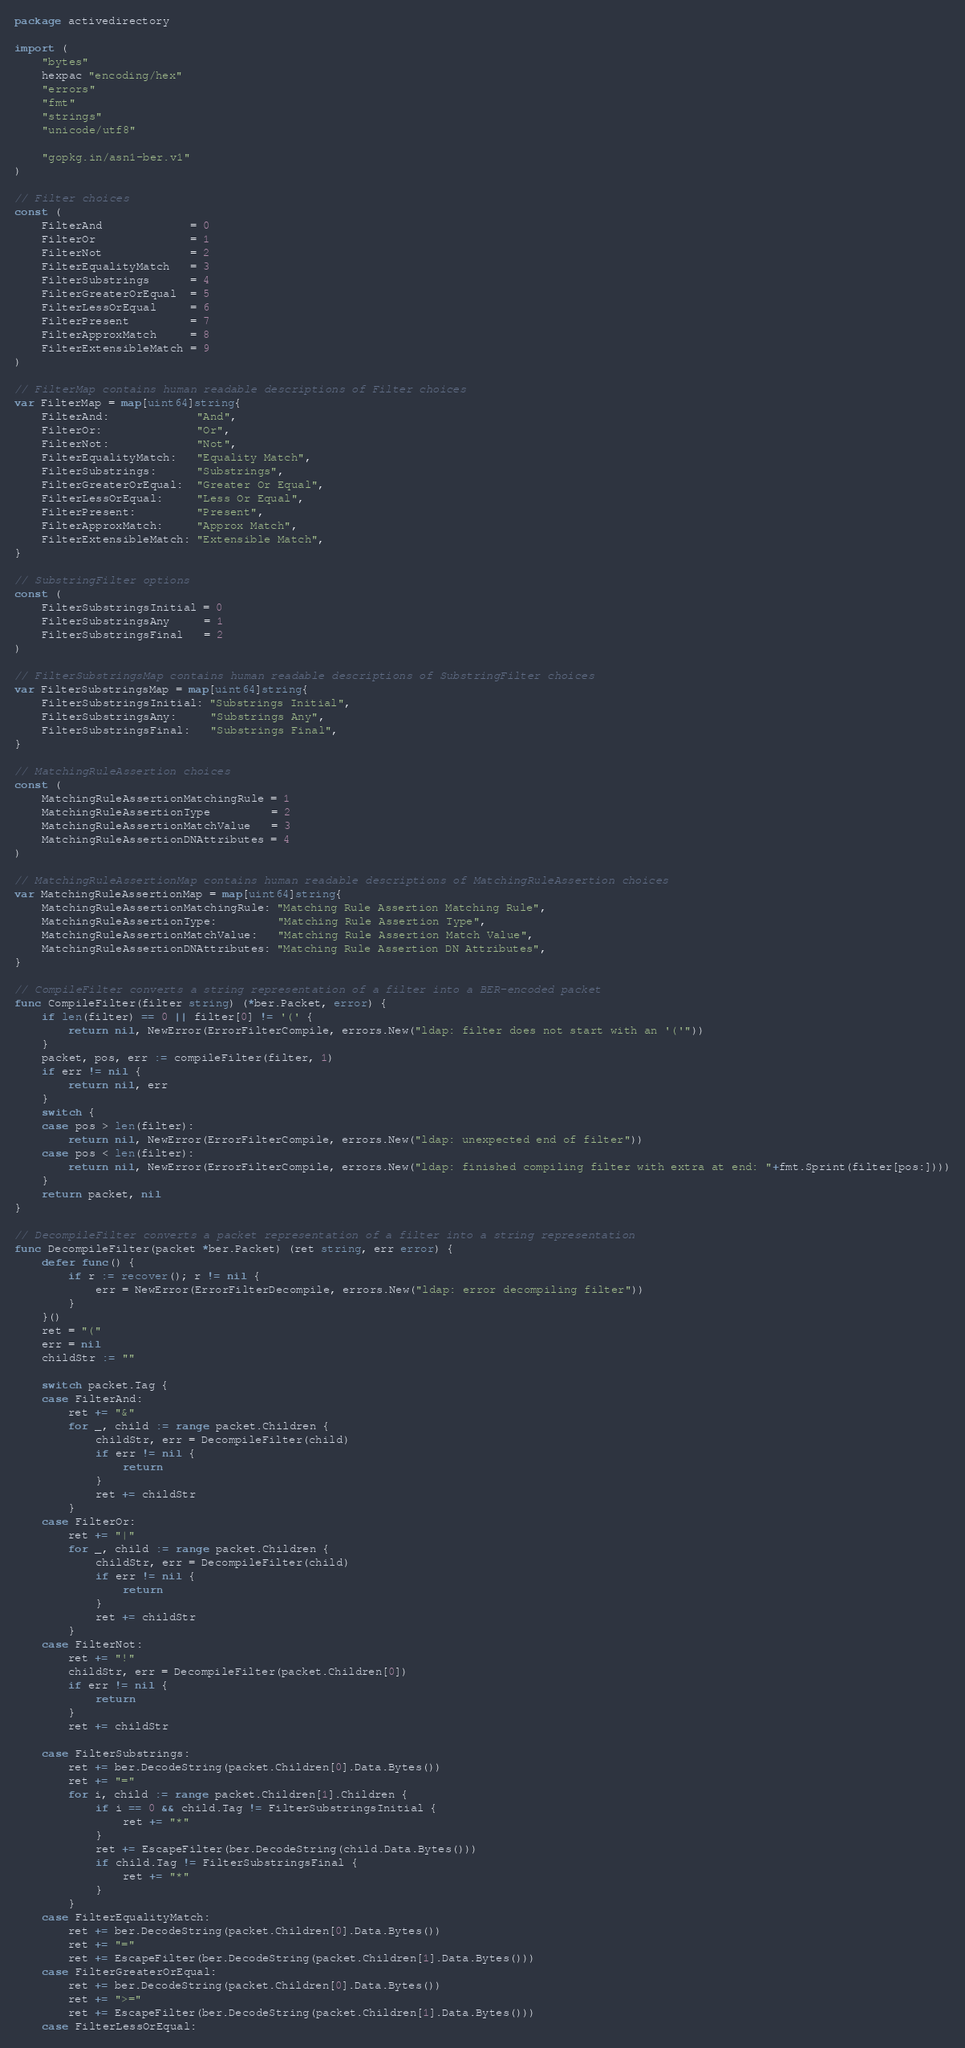Convert code to text. <code><loc_0><loc_0><loc_500><loc_500><_Go_>package activedirectory

import (
	"bytes"
	hexpac "encoding/hex"
	"errors"
	"fmt"
	"strings"
	"unicode/utf8"

	"gopkg.in/asn1-ber.v1"
)

// Filter choices
const (
	FilterAnd             = 0
	FilterOr              = 1
	FilterNot             = 2
	FilterEqualityMatch   = 3
	FilterSubstrings      = 4
	FilterGreaterOrEqual  = 5
	FilterLessOrEqual     = 6
	FilterPresent         = 7
	FilterApproxMatch     = 8
	FilterExtensibleMatch = 9
)

// FilterMap contains human readable descriptions of Filter choices
var FilterMap = map[uint64]string{
	FilterAnd:             "And",
	FilterOr:              "Or",
	FilterNot:             "Not",
	FilterEqualityMatch:   "Equality Match",
	FilterSubstrings:      "Substrings",
	FilterGreaterOrEqual:  "Greater Or Equal",
	FilterLessOrEqual:     "Less Or Equal",
	FilterPresent:         "Present",
	FilterApproxMatch:     "Approx Match",
	FilterExtensibleMatch: "Extensible Match",
}

// SubstringFilter options
const (
	FilterSubstringsInitial = 0
	FilterSubstringsAny     = 1
	FilterSubstringsFinal   = 2
)

// FilterSubstringsMap contains human readable descriptions of SubstringFilter choices
var FilterSubstringsMap = map[uint64]string{
	FilterSubstringsInitial: "Substrings Initial",
	FilterSubstringsAny:     "Substrings Any",
	FilterSubstringsFinal:   "Substrings Final",
}

// MatchingRuleAssertion choices
const (
	MatchingRuleAssertionMatchingRule = 1
	MatchingRuleAssertionType         = 2
	MatchingRuleAssertionMatchValue   = 3
	MatchingRuleAssertionDNAttributes = 4
)

// MatchingRuleAssertionMap contains human readable descriptions of MatchingRuleAssertion choices
var MatchingRuleAssertionMap = map[uint64]string{
	MatchingRuleAssertionMatchingRule: "Matching Rule Assertion Matching Rule",
	MatchingRuleAssertionType:         "Matching Rule Assertion Type",
	MatchingRuleAssertionMatchValue:   "Matching Rule Assertion Match Value",
	MatchingRuleAssertionDNAttributes: "Matching Rule Assertion DN Attributes",
}

// CompileFilter converts a string representation of a filter into a BER-encoded packet
func CompileFilter(filter string) (*ber.Packet, error) {
	if len(filter) == 0 || filter[0] != '(' {
		return nil, NewError(ErrorFilterCompile, errors.New("ldap: filter does not start with an '('"))
	}
	packet, pos, err := compileFilter(filter, 1)
	if err != nil {
		return nil, err
	}
	switch {
	case pos > len(filter):
		return nil, NewError(ErrorFilterCompile, errors.New("ldap: unexpected end of filter"))
	case pos < len(filter):
		return nil, NewError(ErrorFilterCompile, errors.New("ldap: finished compiling filter with extra at end: "+fmt.Sprint(filter[pos:])))
	}
	return packet, nil
}

// DecompileFilter converts a packet representation of a filter into a string representation
func DecompileFilter(packet *ber.Packet) (ret string, err error) {
	defer func() {
		if r := recover(); r != nil {
			err = NewError(ErrorFilterDecompile, errors.New("ldap: error decompiling filter"))
		}
	}()
	ret = "("
	err = nil
	childStr := ""

	switch packet.Tag {
	case FilterAnd:
		ret += "&"
		for _, child := range packet.Children {
			childStr, err = DecompileFilter(child)
			if err != nil {
				return
			}
			ret += childStr
		}
	case FilterOr:
		ret += "|"
		for _, child := range packet.Children {
			childStr, err = DecompileFilter(child)
			if err != nil {
				return
			}
			ret += childStr
		}
	case FilterNot:
		ret += "!"
		childStr, err = DecompileFilter(packet.Children[0])
		if err != nil {
			return
		}
		ret += childStr

	case FilterSubstrings:
		ret += ber.DecodeString(packet.Children[0].Data.Bytes())
		ret += "="
		for i, child := range packet.Children[1].Children {
			if i == 0 && child.Tag != FilterSubstringsInitial {
				ret += "*"
			}
			ret += EscapeFilter(ber.DecodeString(child.Data.Bytes()))
			if child.Tag != FilterSubstringsFinal {
				ret += "*"
			}
		}
	case FilterEqualityMatch:
		ret += ber.DecodeString(packet.Children[0].Data.Bytes())
		ret += "="
		ret += EscapeFilter(ber.DecodeString(packet.Children[1].Data.Bytes()))
	case FilterGreaterOrEqual:
		ret += ber.DecodeString(packet.Children[0].Data.Bytes())
		ret += ">="
		ret += EscapeFilter(ber.DecodeString(packet.Children[1].Data.Bytes()))
	case FilterLessOrEqual:</code> 